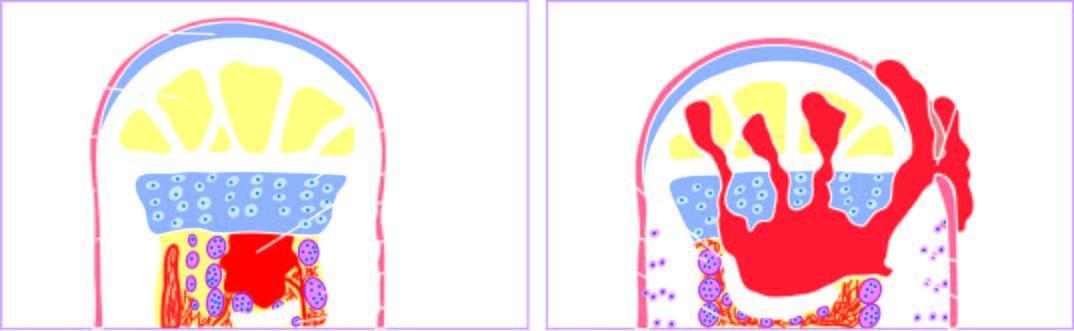what expands further causing necrosis of the cortex called sequestrum?
Answer the question using a single word or phrase. Abscess 